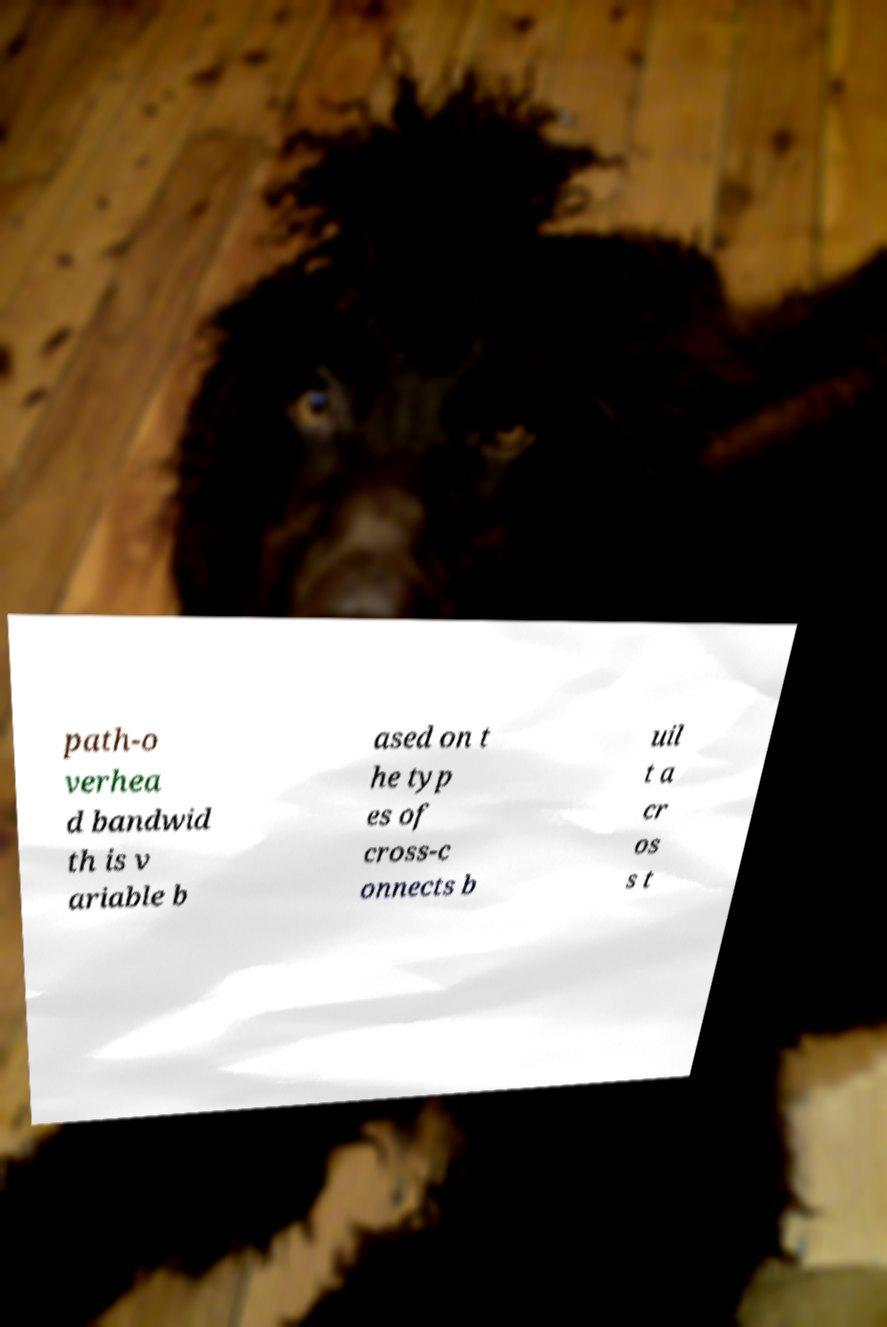Can you accurately transcribe the text from the provided image for me? path-o verhea d bandwid th is v ariable b ased on t he typ es of cross-c onnects b uil t a cr os s t 